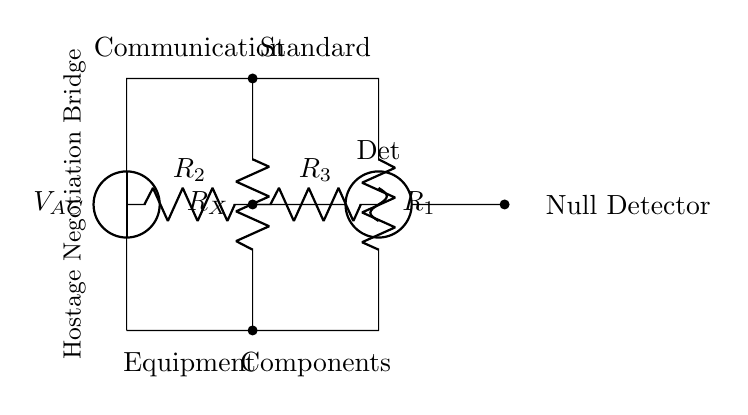What is the type of voltage source in this circuit? The circuit uses an alternating current voltage source, as indicated by the notation of V_AC, which specifies that it is an AC source.
Answer: Alternating current What are the resistors labeled in the circuit? The circuit contains four resistors labeled as R1, R2, R3, and RX. Their specific labels are directly indicated in the diagram.
Answer: R1, R2, R3, RX What is the function of the null detector in this bridge? The null detector is used to determine when the potential difference across its terminals is zero, indicating that the bridge is balanced, which can confirm the integrity of the communication equipment.
Answer: Measure balance How is the communication equipment connected in the circuit? The communication equipment is connected in parallel to RX across the voltage source and is part of the bridge configuration to test its functionality by comparing it to standard components.
Answer: In parallel Why is the bridge setup significant for testing equipment? The bridge setup allows for precise comparisons between an unknown resistor (RX) and known standards (R2 and R3), facilitating accurate testing and validation of the communication equipment's performance.
Answer: Accurate testing 